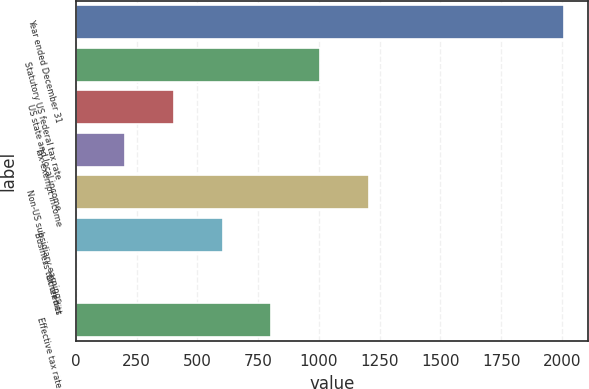<chart> <loc_0><loc_0><loc_500><loc_500><bar_chart><fcel>Year ended December 31<fcel>Statutory US federal tax rate<fcel>US state and local income<fcel>Tax-exempt income<fcel>Non-US subsidiary earnings<fcel>Business tax credits<fcel>Other net<fcel>Effective tax rate<nl><fcel>2008<fcel>1005.4<fcel>403.84<fcel>203.32<fcel>1205.92<fcel>604.36<fcel>2.8<fcel>804.88<nl></chart> 